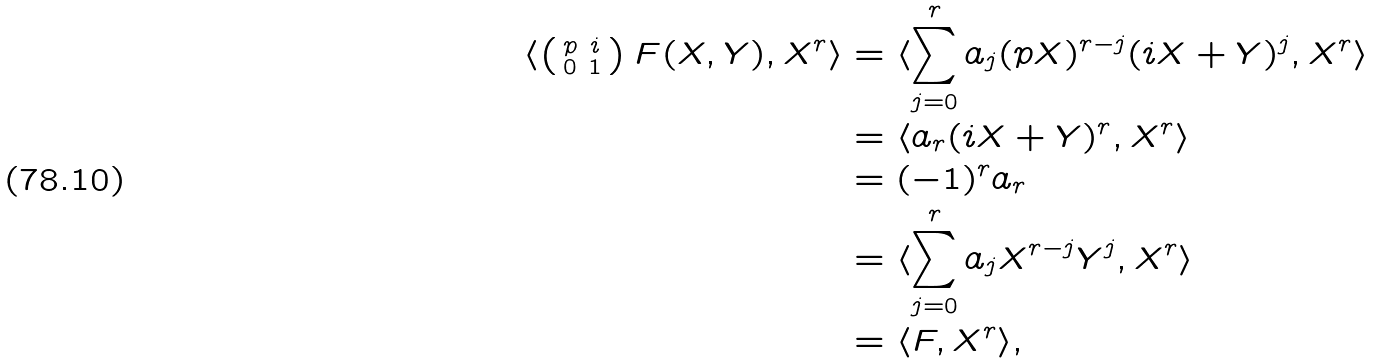Convert formula to latex. <formula><loc_0><loc_0><loc_500><loc_500>\langle \left ( \begin{smallmatrix} p & i \\ 0 & 1 \end{smallmatrix} \right ) F ( X , Y ) , X ^ { r } \rangle & = \langle \sum _ { j = 0 } ^ { r } a _ { j } ( p X ) ^ { r - j } ( i X + Y ) ^ { j } , X ^ { r } \rangle \\ & = \langle a _ { r } ( i X + Y ) ^ { r } , X ^ { r } \rangle \\ & = ( - 1 ) ^ { r } a _ { r } \\ & = \langle \sum _ { j = 0 } ^ { r } a _ { j } X ^ { r - j } Y ^ { j } , X ^ { r } \rangle \\ & = \langle F , X ^ { r } \rangle ,</formula> 